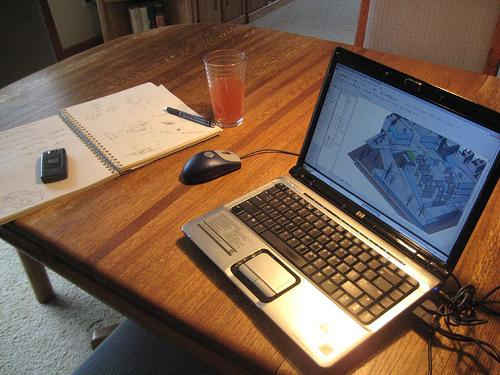What is the computer most at risk of? Please explain your reasoning. fire hazard. The computer is most at risk of fire because of all of the wires. 